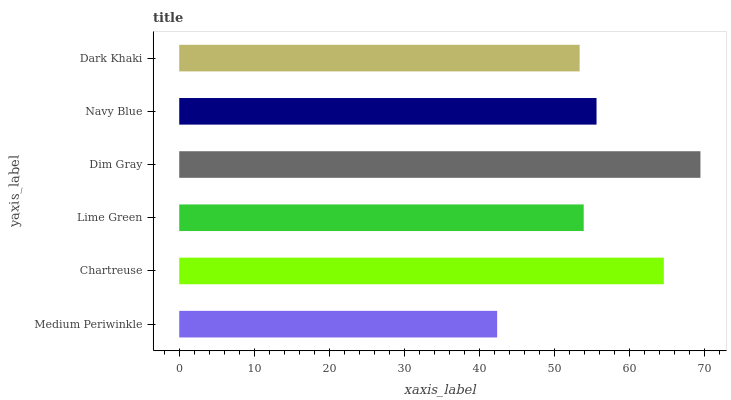Is Medium Periwinkle the minimum?
Answer yes or no. Yes. Is Dim Gray the maximum?
Answer yes or no. Yes. Is Chartreuse the minimum?
Answer yes or no. No. Is Chartreuse the maximum?
Answer yes or no. No. Is Chartreuse greater than Medium Periwinkle?
Answer yes or no. Yes. Is Medium Periwinkle less than Chartreuse?
Answer yes or no. Yes. Is Medium Periwinkle greater than Chartreuse?
Answer yes or no. No. Is Chartreuse less than Medium Periwinkle?
Answer yes or no. No. Is Navy Blue the high median?
Answer yes or no. Yes. Is Lime Green the low median?
Answer yes or no. Yes. Is Medium Periwinkle the high median?
Answer yes or no. No. Is Navy Blue the low median?
Answer yes or no. No. 